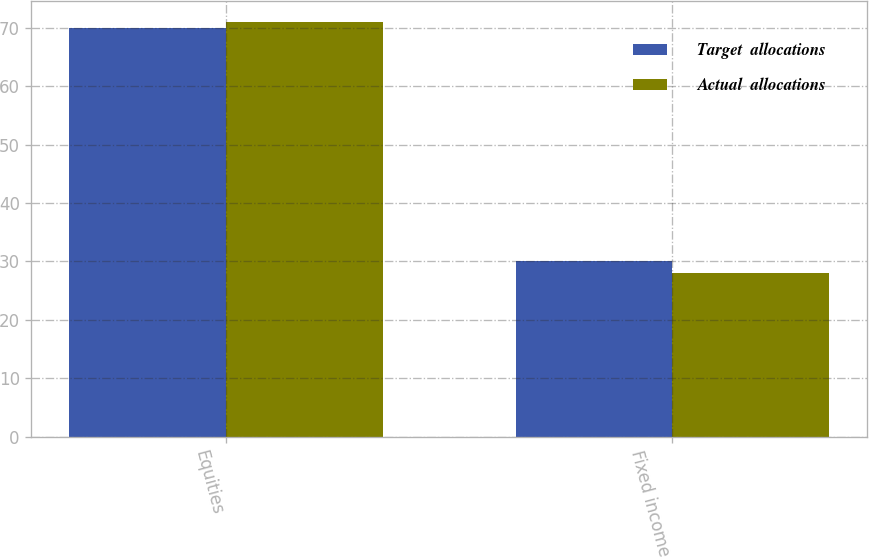Convert chart to OTSL. <chart><loc_0><loc_0><loc_500><loc_500><stacked_bar_chart><ecel><fcel>Equities<fcel>Fixed income<nl><fcel>Target  allocations<fcel>70<fcel>30<nl><fcel>Actual  allocations<fcel>71<fcel>28<nl></chart> 